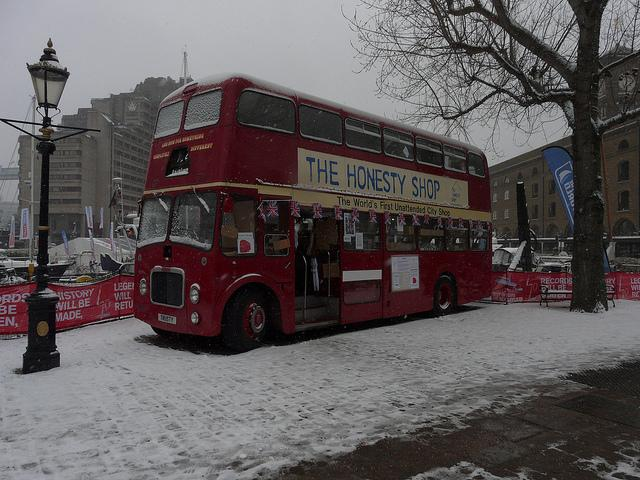Which side of the bus can people enter through?

Choices:
A) driver side
B) back side
C) passenger side
D) top side driver side 